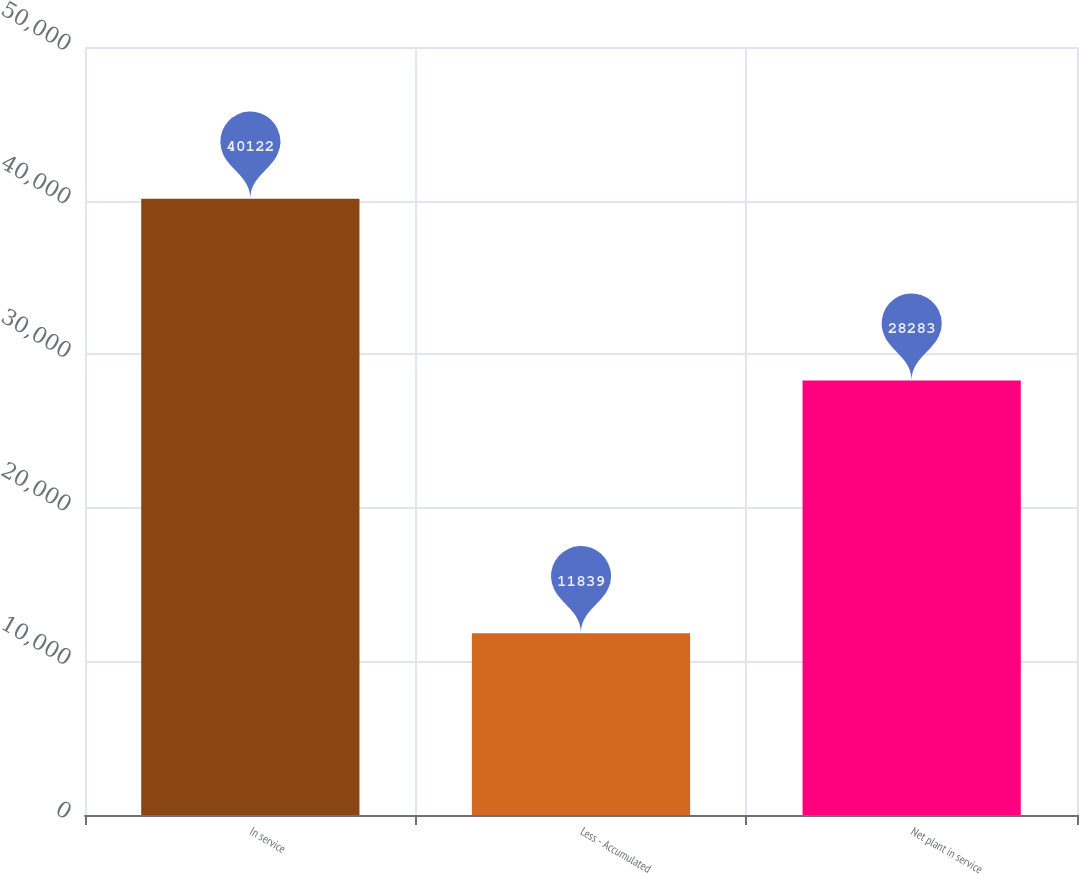Convert chart to OTSL. <chart><loc_0><loc_0><loc_500><loc_500><bar_chart><fcel>In service<fcel>Less - Accumulated<fcel>Net plant in service<nl><fcel>40122<fcel>11839<fcel>28283<nl></chart> 